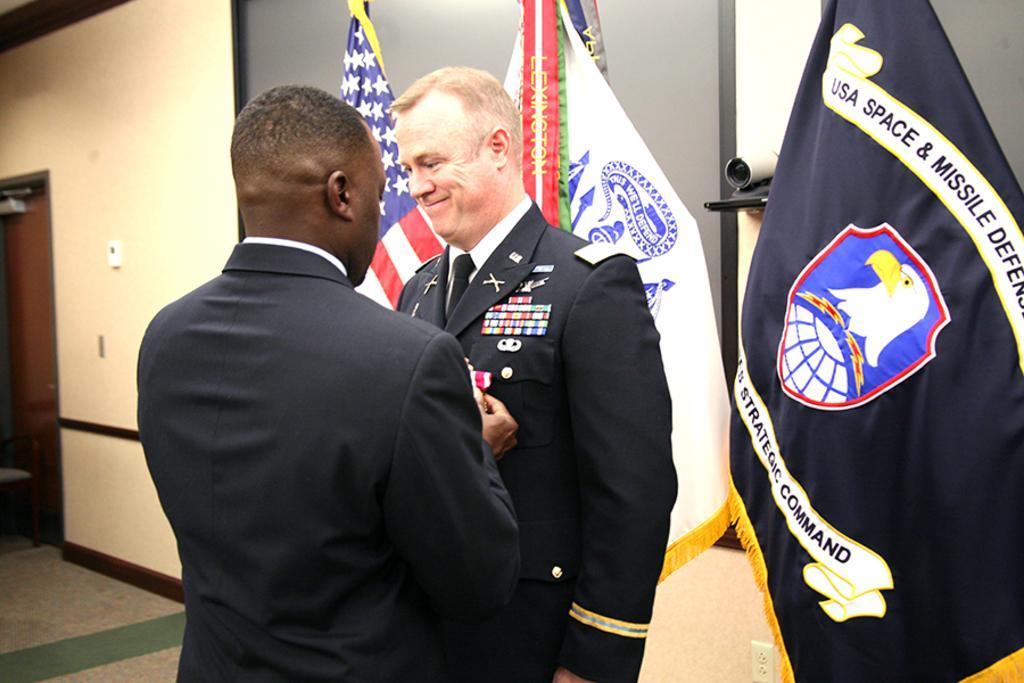Could you give a brief overview of what you see in this image? This picture is taken inside the room. In this image, in the middle, we can see two men wearing a black color dress. On the right side, we can see a black color flag. In the background, we can also see two flags. On the left side, we can see a door which is closed and a wall. 